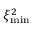Convert formula to latex. <formula><loc_0><loc_0><loc_500><loc_500>\xi _ { \min } ^ { 2 }</formula> 